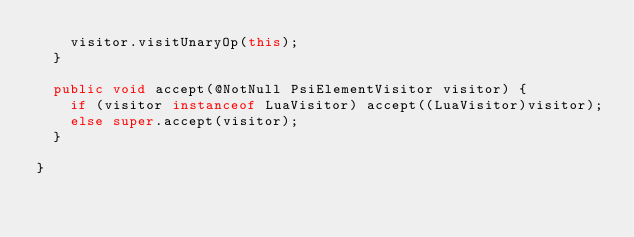<code> <loc_0><loc_0><loc_500><loc_500><_Java_>    visitor.visitUnaryOp(this);
  }

  public void accept(@NotNull PsiElementVisitor visitor) {
    if (visitor instanceof LuaVisitor) accept((LuaVisitor)visitor);
    else super.accept(visitor);
  }

}
</code> 